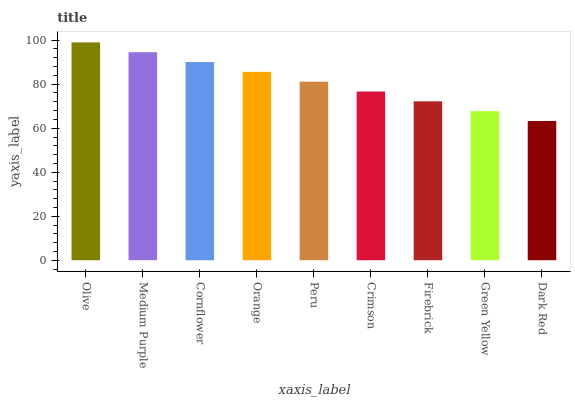Is Dark Red the minimum?
Answer yes or no. Yes. Is Olive the maximum?
Answer yes or no. Yes. Is Medium Purple the minimum?
Answer yes or no. No. Is Medium Purple the maximum?
Answer yes or no. No. Is Olive greater than Medium Purple?
Answer yes or no. Yes. Is Medium Purple less than Olive?
Answer yes or no. Yes. Is Medium Purple greater than Olive?
Answer yes or no. No. Is Olive less than Medium Purple?
Answer yes or no. No. Is Peru the high median?
Answer yes or no. Yes. Is Peru the low median?
Answer yes or no. Yes. Is Cornflower the high median?
Answer yes or no. No. Is Cornflower the low median?
Answer yes or no. No. 